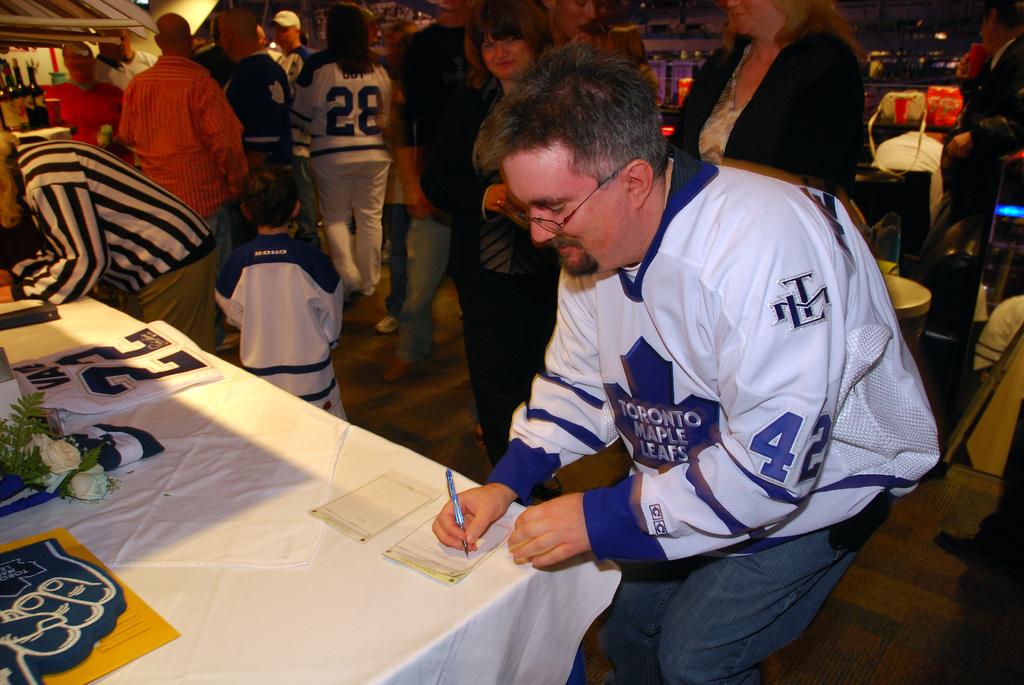What is the number on the football shirt?
Your response must be concise. 42. What is the number of the jersey on the table?
Provide a succinct answer. 22. 